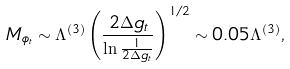<formula> <loc_0><loc_0><loc_500><loc_500>M _ { \phi _ { t } } \sim \Lambda ^ { ( 3 ) } \left ( \frac { 2 \Delta g _ { t } } { \ln \frac { 1 } { 2 \Delta g _ { t } } } \right ) ^ { 1 / 2 } \sim 0 . 0 5 \Lambda ^ { ( 3 ) } ,</formula> 